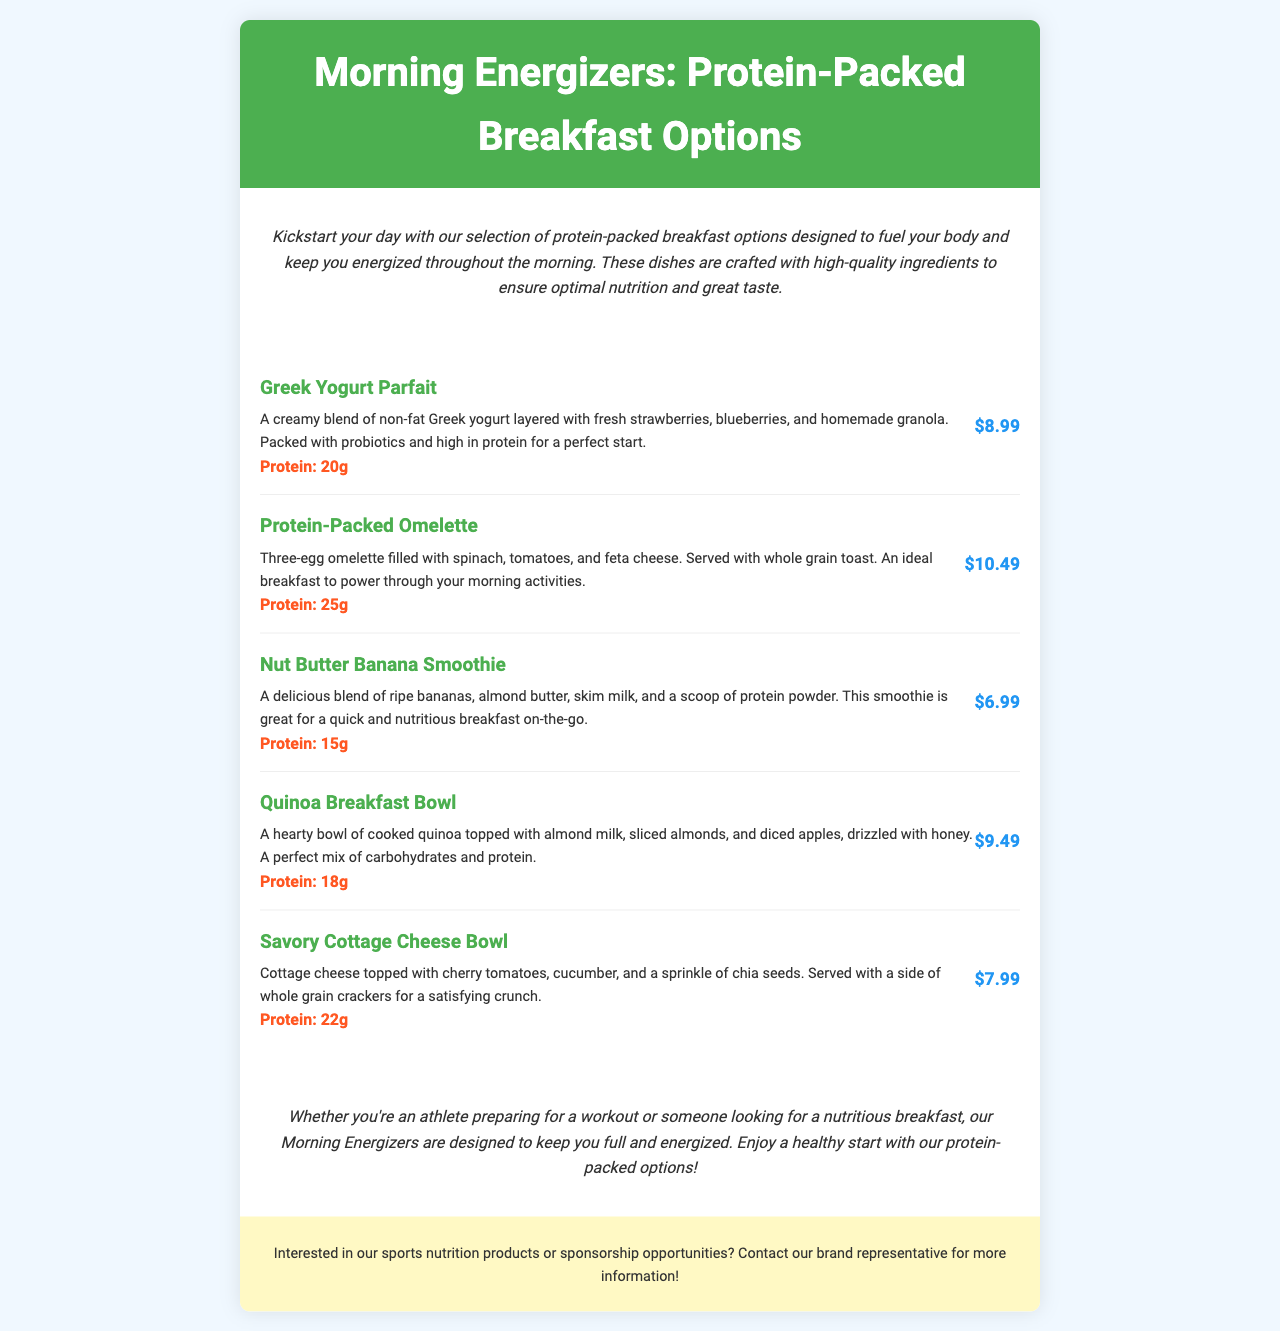What is the first item on the menu? The first item listed in the menu is "Greek Yogurt Parfait."
Answer: Greek Yogurt Parfait How much protein does the Protein-Packed Omelette contain? The protein content is specified directly under the Protein-Packed Omelette description as 25g.
Answer: 25g What is the price of the Nut Butter Banana Smoothie? The price is clearly stated next to the Nut Butter Banana Smoothie, which is $6.99.
Answer: $6.99 Which breakfast option has the highest protein content? A comparison of the protein values in the menu shows that the Protein-Packed Omelette has the highest at 25g.
Answer: Protein-Packed Omelette What type of yogurt is used in the Greek Yogurt Parfait? The description of the Greek Yogurt Parfait specifies that it uses non-fat Greek yogurt.
Answer: non-fat Greek yogurt What is the total price of the Quinoa Breakfast Bowl and Savory Cottage Cheese Bowl? The prices are provided, with the Quinoa Breakfast Bowl at $9.49 and the Savory Cottage Cheese Bowl at $7.99; adding these gives the total.
Answer: $17.48 Which dish is described as a quick breakfast on-the-go? The Nut Butter Banana Smoothie is specifically described as great for a quick breakfast on-the-go.
Answer: Nut Butter Banana Smoothie How many eggs are used in the Protein-Packed Omelette? The description states that the Protein-Packed Omelette is a three-egg omelette.
Answer: three eggs What is included with the Savory Cottage Cheese Bowl? The description mentions that the Savory Cottage Cheese Bowl is served with a side of whole grain crackers.
Answer: whole grain crackers 